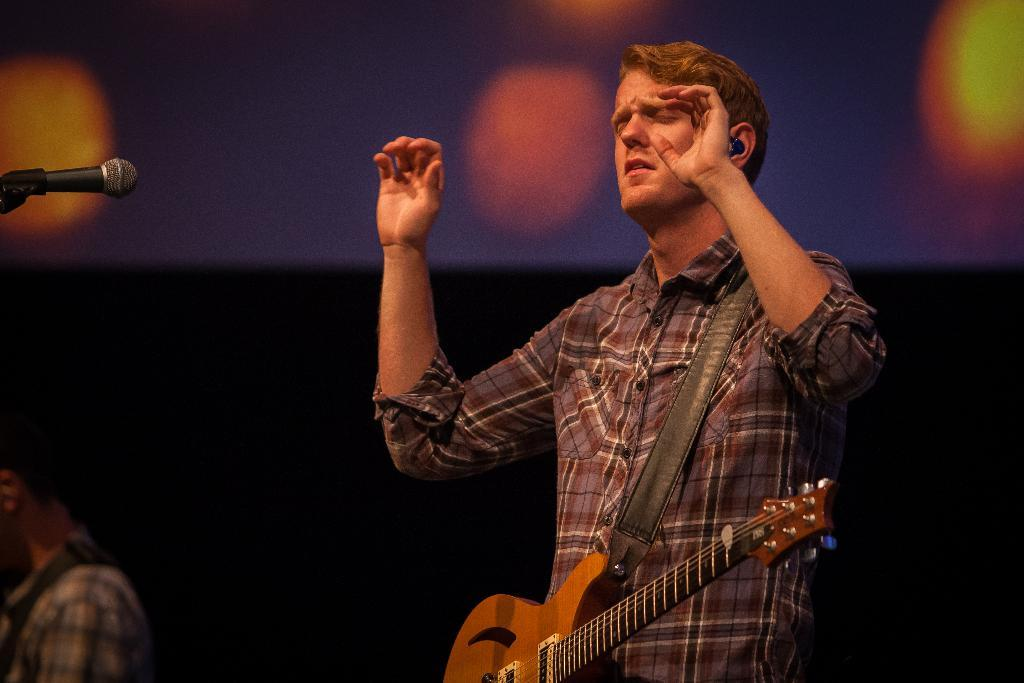What is the man in the image holding? The man is holding a guitar. What object is in front of the man? There is a microphone in front of the man. Is there anyone else in the image besides the man? Yes, there is a person beside the man. How many ants can be seen crawling on the guitar in the image? There are no ants present in the image, and therefore no ants can be seen on the guitar. What type of drink is the man's uncle holding in the image? There is no uncle or drink present in the image. 